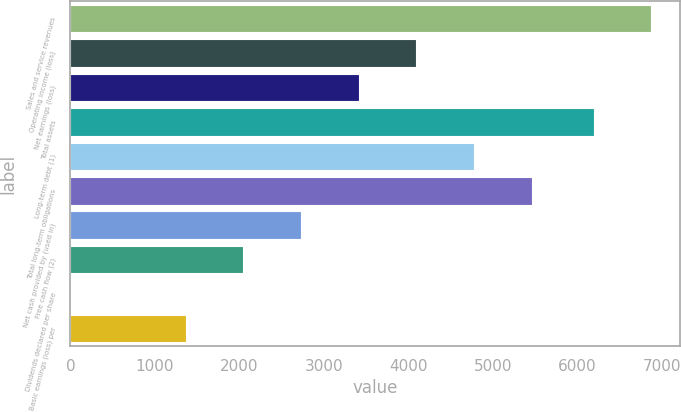Convert chart to OTSL. <chart><loc_0><loc_0><loc_500><loc_500><bar_chart><fcel>Sales and service revenues<fcel>Operating income (loss)<fcel>Net earnings (loss)<fcel>Total assets<fcel>Long-term debt (1)<fcel>Total long-term obligations<fcel>Net cash provided by (used in)<fcel>Free cash flow (2)<fcel>Dividends declared per share<fcel>Basic earnings (loss) per<nl><fcel>6871.95<fcel>4092.2<fcel>3410.25<fcel>6190<fcel>4774.15<fcel>5456.1<fcel>2728.3<fcel>2046.35<fcel>0.5<fcel>1364.4<nl></chart> 